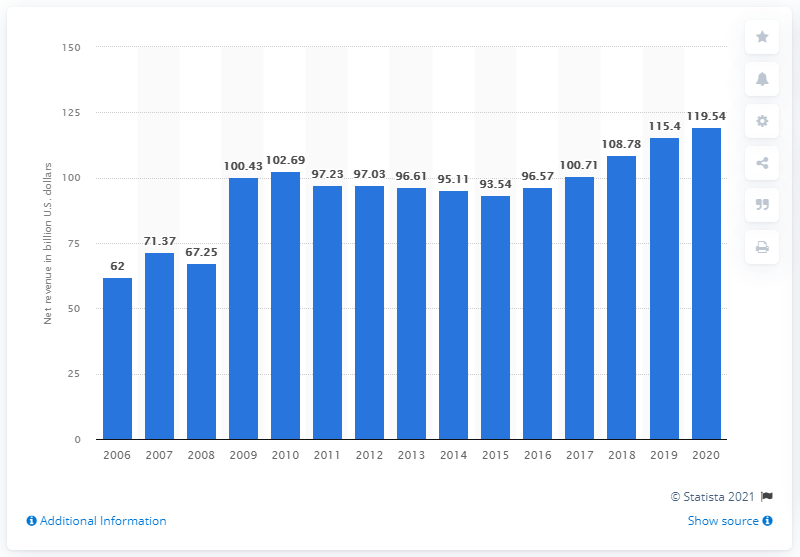Draw attention to some important aspects in this diagram. In 2020, JPMorgan Chase's net revenue was 119.54. 